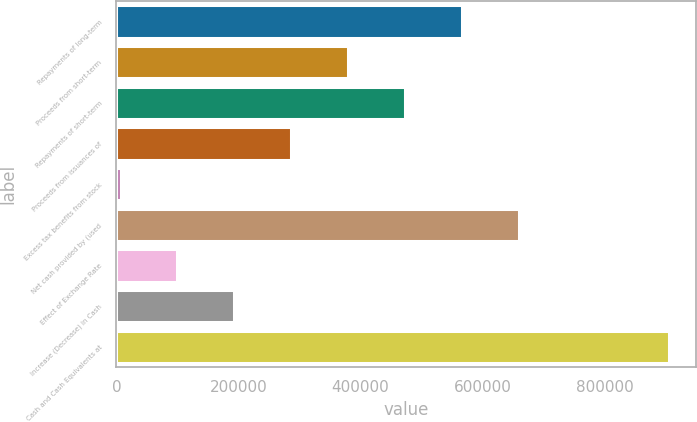Convert chart. <chart><loc_0><loc_0><loc_500><loc_500><bar_chart><fcel>Repayments of long-term<fcel>Proceeds from short-term<fcel>Repayments of short-term<fcel>Proceeds from issuances of<fcel>Excess tax benefits from stock<fcel>Net cash provided by (used<fcel>Effect of Exchange Rate<fcel>Increase (Decrease) in Cash<fcel>Cash and Cash Equivalents at<nl><fcel>566040<fcel>379639<fcel>472840<fcel>286438<fcel>6837<fcel>659240<fcel>100038<fcel>193238<fcel>905633<nl></chart> 